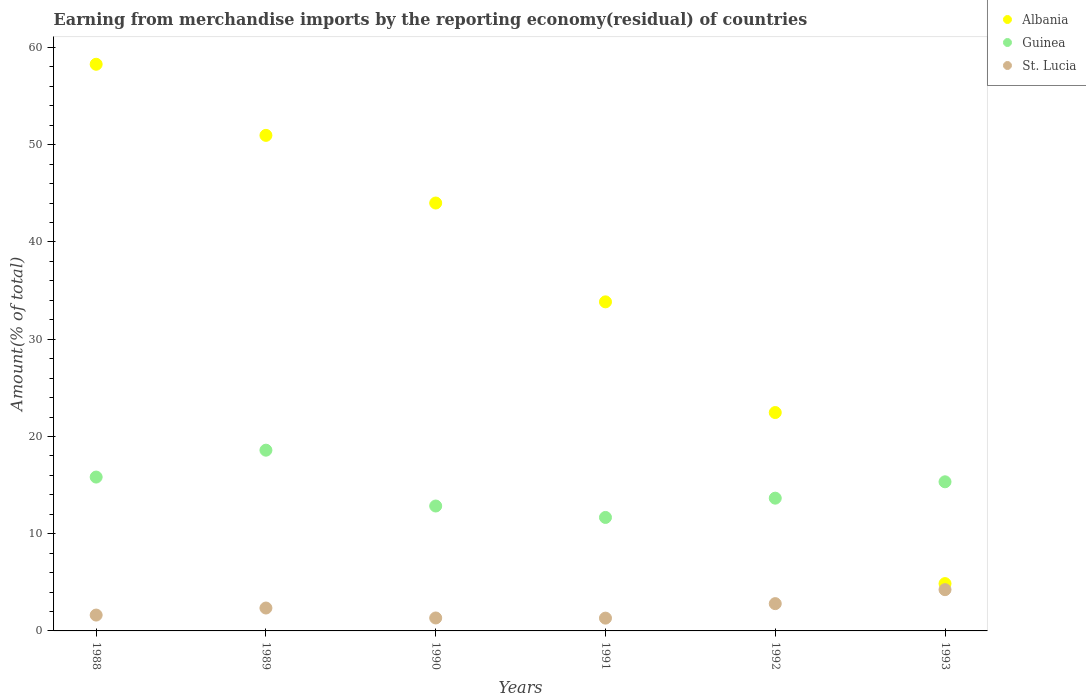What is the percentage of amount earned from merchandise imports in Guinea in 1993?
Keep it short and to the point. 15.34. Across all years, what is the maximum percentage of amount earned from merchandise imports in St. Lucia?
Your answer should be very brief. 4.24. Across all years, what is the minimum percentage of amount earned from merchandise imports in Albania?
Provide a succinct answer. 4.87. In which year was the percentage of amount earned from merchandise imports in Guinea maximum?
Provide a short and direct response. 1989. What is the total percentage of amount earned from merchandise imports in St. Lucia in the graph?
Keep it short and to the point. 13.68. What is the difference between the percentage of amount earned from merchandise imports in St. Lucia in 1989 and that in 1990?
Give a very brief answer. 1.02. What is the difference between the percentage of amount earned from merchandise imports in Guinea in 1991 and the percentage of amount earned from merchandise imports in Albania in 1988?
Your answer should be compact. -46.61. What is the average percentage of amount earned from merchandise imports in St. Lucia per year?
Your answer should be compact. 2.28. In the year 1993, what is the difference between the percentage of amount earned from merchandise imports in Albania and percentage of amount earned from merchandise imports in Guinea?
Your response must be concise. -10.47. In how many years, is the percentage of amount earned from merchandise imports in Guinea greater than 50 %?
Keep it short and to the point. 0. What is the ratio of the percentage of amount earned from merchandise imports in Albania in 1988 to that in 1993?
Provide a succinct answer. 11.98. What is the difference between the highest and the second highest percentage of amount earned from merchandise imports in St. Lucia?
Offer a terse response. 1.44. What is the difference between the highest and the lowest percentage of amount earned from merchandise imports in Albania?
Offer a terse response. 53.41. Is the sum of the percentage of amount earned from merchandise imports in St. Lucia in 1992 and 1993 greater than the maximum percentage of amount earned from merchandise imports in Albania across all years?
Your response must be concise. No. Is it the case that in every year, the sum of the percentage of amount earned from merchandise imports in Guinea and percentage of amount earned from merchandise imports in St. Lucia  is greater than the percentage of amount earned from merchandise imports in Albania?
Provide a short and direct response. No. Is the percentage of amount earned from merchandise imports in St. Lucia strictly less than the percentage of amount earned from merchandise imports in Guinea over the years?
Your answer should be compact. Yes. How many dotlines are there?
Make the answer very short. 3. Are the values on the major ticks of Y-axis written in scientific E-notation?
Provide a short and direct response. No. Does the graph contain grids?
Provide a short and direct response. No. Where does the legend appear in the graph?
Offer a terse response. Top right. What is the title of the graph?
Provide a succinct answer. Earning from merchandise imports by the reporting economy(residual) of countries. Does "Angola" appear as one of the legend labels in the graph?
Make the answer very short. No. What is the label or title of the Y-axis?
Offer a very short reply. Amount(% of total). What is the Amount(% of total) of Albania in 1988?
Keep it short and to the point. 58.28. What is the Amount(% of total) in Guinea in 1988?
Keep it short and to the point. 15.82. What is the Amount(% of total) in St. Lucia in 1988?
Offer a very short reply. 1.63. What is the Amount(% of total) in Albania in 1989?
Your response must be concise. 50.96. What is the Amount(% of total) in Guinea in 1989?
Your answer should be very brief. 18.59. What is the Amount(% of total) in St. Lucia in 1989?
Your answer should be compact. 2.35. What is the Amount(% of total) of Albania in 1990?
Offer a terse response. 44.01. What is the Amount(% of total) of Guinea in 1990?
Provide a short and direct response. 12.85. What is the Amount(% of total) of St. Lucia in 1990?
Keep it short and to the point. 1.33. What is the Amount(% of total) in Albania in 1991?
Offer a very short reply. 33.84. What is the Amount(% of total) in Guinea in 1991?
Offer a terse response. 11.67. What is the Amount(% of total) in St. Lucia in 1991?
Keep it short and to the point. 1.32. What is the Amount(% of total) in Albania in 1992?
Ensure brevity in your answer.  22.46. What is the Amount(% of total) of Guinea in 1992?
Keep it short and to the point. 13.65. What is the Amount(% of total) in St. Lucia in 1992?
Your answer should be compact. 2.81. What is the Amount(% of total) in Albania in 1993?
Your response must be concise. 4.87. What is the Amount(% of total) of Guinea in 1993?
Give a very brief answer. 15.34. What is the Amount(% of total) in St. Lucia in 1993?
Provide a short and direct response. 4.24. Across all years, what is the maximum Amount(% of total) in Albania?
Offer a very short reply. 58.28. Across all years, what is the maximum Amount(% of total) in Guinea?
Offer a very short reply. 18.59. Across all years, what is the maximum Amount(% of total) of St. Lucia?
Your answer should be very brief. 4.24. Across all years, what is the minimum Amount(% of total) in Albania?
Your answer should be very brief. 4.87. Across all years, what is the minimum Amount(% of total) in Guinea?
Offer a very short reply. 11.67. Across all years, what is the minimum Amount(% of total) in St. Lucia?
Keep it short and to the point. 1.32. What is the total Amount(% of total) in Albania in the graph?
Make the answer very short. 214.41. What is the total Amount(% of total) of Guinea in the graph?
Give a very brief answer. 87.92. What is the total Amount(% of total) in St. Lucia in the graph?
Make the answer very short. 13.68. What is the difference between the Amount(% of total) in Albania in 1988 and that in 1989?
Your answer should be very brief. 7.31. What is the difference between the Amount(% of total) of Guinea in 1988 and that in 1989?
Your response must be concise. -2.77. What is the difference between the Amount(% of total) in St. Lucia in 1988 and that in 1989?
Provide a short and direct response. -0.72. What is the difference between the Amount(% of total) in Albania in 1988 and that in 1990?
Your response must be concise. 14.27. What is the difference between the Amount(% of total) of Guinea in 1988 and that in 1990?
Keep it short and to the point. 2.98. What is the difference between the Amount(% of total) of St. Lucia in 1988 and that in 1990?
Provide a succinct answer. 0.3. What is the difference between the Amount(% of total) of Albania in 1988 and that in 1991?
Give a very brief answer. 24.43. What is the difference between the Amount(% of total) of Guinea in 1988 and that in 1991?
Give a very brief answer. 4.15. What is the difference between the Amount(% of total) of St. Lucia in 1988 and that in 1991?
Your answer should be very brief. 0.32. What is the difference between the Amount(% of total) in Albania in 1988 and that in 1992?
Offer a very short reply. 35.82. What is the difference between the Amount(% of total) in Guinea in 1988 and that in 1992?
Provide a succinct answer. 2.17. What is the difference between the Amount(% of total) in St. Lucia in 1988 and that in 1992?
Make the answer very short. -1.18. What is the difference between the Amount(% of total) of Albania in 1988 and that in 1993?
Make the answer very short. 53.41. What is the difference between the Amount(% of total) in Guinea in 1988 and that in 1993?
Offer a terse response. 0.49. What is the difference between the Amount(% of total) of St. Lucia in 1988 and that in 1993?
Your answer should be compact. -2.61. What is the difference between the Amount(% of total) in Albania in 1989 and that in 1990?
Provide a short and direct response. 6.96. What is the difference between the Amount(% of total) in Guinea in 1989 and that in 1990?
Your response must be concise. 5.74. What is the difference between the Amount(% of total) of St. Lucia in 1989 and that in 1990?
Offer a terse response. 1.02. What is the difference between the Amount(% of total) of Albania in 1989 and that in 1991?
Provide a short and direct response. 17.12. What is the difference between the Amount(% of total) in Guinea in 1989 and that in 1991?
Make the answer very short. 6.92. What is the difference between the Amount(% of total) in St. Lucia in 1989 and that in 1991?
Offer a very short reply. 1.04. What is the difference between the Amount(% of total) of Albania in 1989 and that in 1992?
Offer a terse response. 28.5. What is the difference between the Amount(% of total) of Guinea in 1989 and that in 1992?
Make the answer very short. 4.94. What is the difference between the Amount(% of total) of St. Lucia in 1989 and that in 1992?
Make the answer very short. -0.45. What is the difference between the Amount(% of total) of Albania in 1989 and that in 1993?
Keep it short and to the point. 46.1. What is the difference between the Amount(% of total) in Guinea in 1989 and that in 1993?
Offer a terse response. 3.25. What is the difference between the Amount(% of total) of St. Lucia in 1989 and that in 1993?
Make the answer very short. -1.89. What is the difference between the Amount(% of total) of Albania in 1990 and that in 1991?
Your answer should be very brief. 10.16. What is the difference between the Amount(% of total) of Guinea in 1990 and that in 1991?
Provide a short and direct response. 1.17. What is the difference between the Amount(% of total) of St. Lucia in 1990 and that in 1991?
Offer a very short reply. 0.02. What is the difference between the Amount(% of total) of Albania in 1990 and that in 1992?
Your answer should be compact. 21.55. What is the difference between the Amount(% of total) of Guinea in 1990 and that in 1992?
Your answer should be compact. -0.81. What is the difference between the Amount(% of total) in St. Lucia in 1990 and that in 1992?
Make the answer very short. -1.47. What is the difference between the Amount(% of total) of Albania in 1990 and that in 1993?
Offer a terse response. 39.14. What is the difference between the Amount(% of total) of Guinea in 1990 and that in 1993?
Offer a very short reply. -2.49. What is the difference between the Amount(% of total) in St. Lucia in 1990 and that in 1993?
Make the answer very short. -2.91. What is the difference between the Amount(% of total) of Albania in 1991 and that in 1992?
Your answer should be very brief. 11.38. What is the difference between the Amount(% of total) of Guinea in 1991 and that in 1992?
Your response must be concise. -1.98. What is the difference between the Amount(% of total) in St. Lucia in 1991 and that in 1992?
Your response must be concise. -1.49. What is the difference between the Amount(% of total) of Albania in 1991 and that in 1993?
Provide a succinct answer. 28.98. What is the difference between the Amount(% of total) in Guinea in 1991 and that in 1993?
Give a very brief answer. -3.67. What is the difference between the Amount(% of total) of St. Lucia in 1991 and that in 1993?
Make the answer very short. -2.93. What is the difference between the Amount(% of total) of Albania in 1992 and that in 1993?
Your answer should be compact. 17.59. What is the difference between the Amount(% of total) of Guinea in 1992 and that in 1993?
Provide a short and direct response. -1.68. What is the difference between the Amount(% of total) of St. Lucia in 1992 and that in 1993?
Your response must be concise. -1.44. What is the difference between the Amount(% of total) in Albania in 1988 and the Amount(% of total) in Guinea in 1989?
Make the answer very short. 39.69. What is the difference between the Amount(% of total) of Albania in 1988 and the Amount(% of total) of St. Lucia in 1989?
Give a very brief answer. 55.92. What is the difference between the Amount(% of total) in Guinea in 1988 and the Amount(% of total) in St. Lucia in 1989?
Your answer should be very brief. 13.47. What is the difference between the Amount(% of total) of Albania in 1988 and the Amount(% of total) of Guinea in 1990?
Your answer should be very brief. 45.43. What is the difference between the Amount(% of total) of Albania in 1988 and the Amount(% of total) of St. Lucia in 1990?
Provide a succinct answer. 56.94. What is the difference between the Amount(% of total) in Guinea in 1988 and the Amount(% of total) in St. Lucia in 1990?
Offer a terse response. 14.49. What is the difference between the Amount(% of total) of Albania in 1988 and the Amount(% of total) of Guinea in 1991?
Make the answer very short. 46.61. What is the difference between the Amount(% of total) in Albania in 1988 and the Amount(% of total) in St. Lucia in 1991?
Ensure brevity in your answer.  56.96. What is the difference between the Amount(% of total) in Guinea in 1988 and the Amount(% of total) in St. Lucia in 1991?
Provide a short and direct response. 14.51. What is the difference between the Amount(% of total) of Albania in 1988 and the Amount(% of total) of Guinea in 1992?
Your answer should be compact. 44.62. What is the difference between the Amount(% of total) of Albania in 1988 and the Amount(% of total) of St. Lucia in 1992?
Your answer should be compact. 55.47. What is the difference between the Amount(% of total) of Guinea in 1988 and the Amount(% of total) of St. Lucia in 1992?
Your response must be concise. 13.02. What is the difference between the Amount(% of total) of Albania in 1988 and the Amount(% of total) of Guinea in 1993?
Your response must be concise. 42.94. What is the difference between the Amount(% of total) in Albania in 1988 and the Amount(% of total) in St. Lucia in 1993?
Offer a very short reply. 54.03. What is the difference between the Amount(% of total) of Guinea in 1988 and the Amount(% of total) of St. Lucia in 1993?
Make the answer very short. 11.58. What is the difference between the Amount(% of total) in Albania in 1989 and the Amount(% of total) in Guinea in 1990?
Provide a short and direct response. 38.12. What is the difference between the Amount(% of total) of Albania in 1989 and the Amount(% of total) of St. Lucia in 1990?
Make the answer very short. 49.63. What is the difference between the Amount(% of total) in Guinea in 1989 and the Amount(% of total) in St. Lucia in 1990?
Your answer should be very brief. 17.26. What is the difference between the Amount(% of total) in Albania in 1989 and the Amount(% of total) in Guinea in 1991?
Make the answer very short. 39.29. What is the difference between the Amount(% of total) of Albania in 1989 and the Amount(% of total) of St. Lucia in 1991?
Keep it short and to the point. 49.65. What is the difference between the Amount(% of total) of Guinea in 1989 and the Amount(% of total) of St. Lucia in 1991?
Your answer should be very brief. 17.27. What is the difference between the Amount(% of total) of Albania in 1989 and the Amount(% of total) of Guinea in 1992?
Keep it short and to the point. 37.31. What is the difference between the Amount(% of total) in Albania in 1989 and the Amount(% of total) in St. Lucia in 1992?
Keep it short and to the point. 48.16. What is the difference between the Amount(% of total) of Guinea in 1989 and the Amount(% of total) of St. Lucia in 1992?
Keep it short and to the point. 15.78. What is the difference between the Amount(% of total) in Albania in 1989 and the Amount(% of total) in Guinea in 1993?
Keep it short and to the point. 35.63. What is the difference between the Amount(% of total) of Albania in 1989 and the Amount(% of total) of St. Lucia in 1993?
Make the answer very short. 46.72. What is the difference between the Amount(% of total) of Guinea in 1989 and the Amount(% of total) of St. Lucia in 1993?
Make the answer very short. 14.34. What is the difference between the Amount(% of total) in Albania in 1990 and the Amount(% of total) in Guinea in 1991?
Make the answer very short. 32.34. What is the difference between the Amount(% of total) in Albania in 1990 and the Amount(% of total) in St. Lucia in 1991?
Provide a short and direct response. 42.69. What is the difference between the Amount(% of total) in Guinea in 1990 and the Amount(% of total) in St. Lucia in 1991?
Keep it short and to the point. 11.53. What is the difference between the Amount(% of total) of Albania in 1990 and the Amount(% of total) of Guinea in 1992?
Your response must be concise. 30.35. What is the difference between the Amount(% of total) in Albania in 1990 and the Amount(% of total) in St. Lucia in 1992?
Ensure brevity in your answer.  41.2. What is the difference between the Amount(% of total) in Guinea in 1990 and the Amount(% of total) in St. Lucia in 1992?
Provide a succinct answer. 10.04. What is the difference between the Amount(% of total) of Albania in 1990 and the Amount(% of total) of Guinea in 1993?
Offer a terse response. 28.67. What is the difference between the Amount(% of total) in Albania in 1990 and the Amount(% of total) in St. Lucia in 1993?
Provide a short and direct response. 39.76. What is the difference between the Amount(% of total) of Guinea in 1990 and the Amount(% of total) of St. Lucia in 1993?
Give a very brief answer. 8.6. What is the difference between the Amount(% of total) of Albania in 1991 and the Amount(% of total) of Guinea in 1992?
Keep it short and to the point. 20.19. What is the difference between the Amount(% of total) in Albania in 1991 and the Amount(% of total) in St. Lucia in 1992?
Provide a succinct answer. 31.04. What is the difference between the Amount(% of total) in Guinea in 1991 and the Amount(% of total) in St. Lucia in 1992?
Give a very brief answer. 8.86. What is the difference between the Amount(% of total) in Albania in 1991 and the Amount(% of total) in Guinea in 1993?
Make the answer very short. 18.51. What is the difference between the Amount(% of total) in Albania in 1991 and the Amount(% of total) in St. Lucia in 1993?
Offer a terse response. 29.6. What is the difference between the Amount(% of total) in Guinea in 1991 and the Amount(% of total) in St. Lucia in 1993?
Provide a short and direct response. 7.43. What is the difference between the Amount(% of total) of Albania in 1992 and the Amount(% of total) of Guinea in 1993?
Make the answer very short. 7.12. What is the difference between the Amount(% of total) in Albania in 1992 and the Amount(% of total) in St. Lucia in 1993?
Provide a short and direct response. 18.22. What is the difference between the Amount(% of total) in Guinea in 1992 and the Amount(% of total) in St. Lucia in 1993?
Make the answer very short. 9.41. What is the average Amount(% of total) in Albania per year?
Offer a terse response. 35.74. What is the average Amount(% of total) in Guinea per year?
Provide a short and direct response. 14.65. What is the average Amount(% of total) of St. Lucia per year?
Offer a terse response. 2.28. In the year 1988, what is the difference between the Amount(% of total) of Albania and Amount(% of total) of Guinea?
Make the answer very short. 42.45. In the year 1988, what is the difference between the Amount(% of total) in Albania and Amount(% of total) in St. Lucia?
Give a very brief answer. 56.65. In the year 1988, what is the difference between the Amount(% of total) in Guinea and Amount(% of total) in St. Lucia?
Offer a very short reply. 14.19. In the year 1989, what is the difference between the Amount(% of total) of Albania and Amount(% of total) of Guinea?
Your response must be concise. 32.38. In the year 1989, what is the difference between the Amount(% of total) in Albania and Amount(% of total) in St. Lucia?
Your answer should be very brief. 48.61. In the year 1989, what is the difference between the Amount(% of total) in Guinea and Amount(% of total) in St. Lucia?
Your answer should be compact. 16.23. In the year 1990, what is the difference between the Amount(% of total) in Albania and Amount(% of total) in Guinea?
Offer a very short reply. 31.16. In the year 1990, what is the difference between the Amount(% of total) of Albania and Amount(% of total) of St. Lucia?
Provide a short and direct response. 42.67. In the year 1990, what is the difference between the Amount(% of total) of Guinea and Amount(% of total) of St. Lucia?
Ensure brevity in your answer.  11.51. In the year 1991, what is the difference between the Amount(% of total) of Albania and Amount(% of total) of Guinea?
Ensure brevity in your answer.  22.17. In the year 1991, what is the difference between the Amount(% of total) of Albania and Amount(% of total) of St. Lucia?
Ensure brevity in your answer.  32.53. In the year 1991, what is the difference between the Amount(% of total) of Guinea and Amount(% of total) of St. Lucia?
Your answer should be compact. 10.36. In the year 1992, what is the difference between the Amount(% of total) of Albania and Amount(% of total) of Guinea?
Give a very brief answer. 8.81. In the year 1992, what is the difference between the Amount(% of total) in Albania and Amount(% of total) in St. Lucia?
Ensure brevity in your answer.  19.65. In the year 1992, what is the difference between the Amount(% of total) in Guinea and Amount(% of total) in St. Lucia?
Give a very brief answer. 10.85. In the year 1993, what is the difference between the Amount(% of total) of Albania and Amount(% of total) of Guinea?
Your response must be concise. -10.47. In the year 1993, what is the difference between the Amount(% of total) of Albania and Amount(% of total) of St. Lucia?
Make the answer very short. 0.62. In the year 1993, what is the difference between the Amount(% of total) in Guinea and Amount(% of total) in St. Lucia?
Your answer should be compact. 11.09. What is the ratio of the Amount(% of total) in Albania in 1988 to that in 1989?
Provide a short and direct response. 1.14. What is the ratio of the Amount(% of total) of Guinea in 1988 to that in 1989?
Give a very brief answer. 0.85. What is the ratio of the Amount(% of total) of St. Lucia in 1988 to that in 1989?
Provide a short and direct response. 0.69. What is the ratio of the Amount(% of total) in Albania in 1988 to that in 1990?
Your answer should be very brief. 1.32. What is the ratio of the Amount(% of total) of Guinea in 1988 to that in 1990?
Ensure brevity in your answer.  1.23. What is the ratio of the Amount(% of total) of St. Lucia in 1988 to that in 1990?
Make the answer very short. 1.22. What is the ratio of the Amount(% of total) of Albania in 1988 to that in 1991?
Your answer should be compact. 1.72. What is the ratio of the Amount(% of total) of Guinea in 1988 to that in 1991?
Offer a terse response. 1.36. What is the ratio of the Amount(% of total) in St. Lucia in 1988 to that in 1991?
Your answer should be very brief. 1.24. What is the ratio of the Amount(% of total) in Albania in 1988 to that in 1992?
Your answer should be compact. 2.59. What is the ratio of the Amount(% of total) of Guinea in 1988 to that in 1992?
Provide a short and direct response. 1.16. What is the ratio of the Amount(% of total) of St. Lucia in 1988 to that in 1992?
Offer a very short reply. 0.58. What is the ratio of the Amount(% of total) of Albania in 1988 to that in 1993?
Keep it short and to the point. 11.98. What is the ratio of the Amount(% of total) in Guinea in 1988 to that in 1993?
Make the answer very short. 1.03. What is the ratio of the Amount(% of total) in St. Lucia in 1988 to that in 1993?
Offer a terse response. 0.38. What is the ratio of the Amount(% of total) in Albania in 1989 to that in 1990?
Provide a short and direct response. 1.16. What is the ratio of the Amount(% of total) of Guinea in 1989 to that in 1990?
Your answer should be compact. 1.45. What is the ratio of the Amount(% of total) of St. Lucia in 1989 to that in 1990?
Ensure brevity in your answer.  1.77. What is the ratio of the Amount(% of total) in Albania in 1989 to that in 1991?
Offer a terse response. 1.51. What is the ratio of the Amount(% of total) of Guinea in 1989 to that in 1991?
Give a very brief answer. 1.59. What is the ratio of the Amount(% of total) of St. Lucia in 1989 to that in 1991?
Keep it short and to the point. 1.79. What is the ratio of the Amount(% of total) of Albania in 1989 to that in 1992?
Your answer should be compact. 2.27. What is the ratio of the Amount(% of total) of Guinea in 1989 to that in 1992?
Your answer should be very brief. 1.36. What is the ratio of the Amount(% of total) in St. Lucia in 1989 to that in 1992?
Your answer should be compact. 0.84. What is the ratio of the Amount(% of total) in Albania in 1989 to that in 1993?
Your response must be concise. 10.47. What is the ratio of the Amount(% of total) in Guinea in 1989 to that in 1993?
Make the answer very short. 1.21. What is the ratio of the Amount(% of total) in St. Lucia in 1989 to that in 1993?
Your response must be concise. 0.55. What is the ratio of the Amount(% of total) of Albania in 1990 to that in 1991?
Your answer should be compact. 1.3. What is the ratio of the Amount(% of total) of Guinea in 1990 to that in 1991?
Give a very brief answer. 1.1. What is the ratio of the Amount(% of total) of St. Lucia in 1990 to that in 1991?
Make the answer very short. 1.01. What is the ratio of the Amount(% of total) in Albania in 1990 to that in 1992?
Your answer should be very brief. 1.96. What is the ratio of the Amount(% of total) in Guinea in 1990 to that in 1992?
Your answer should be compact. 0.94. What is the ratio of the Amount(% of total) in St. Lucia in 1990 to that in 1992?
Offer a very short reply. 0.47. What is the ratio of the Amount(% of total) of Albania in 1990 to that in 1993?
Give a very brief answer. 9.04. What is the ratio of the Amount(% of total) of Guinea in 1990 to that in 1993?
Ensure brevity in your answer.  0.84. What is the ratio of the Amount(% of total) in St. Lucia in 1990 to that in 1993?
Your answer should be compact. 0.31. What is the ratio of the Amount(% of total) of Albania in 1991 to that in 1992?
Your answer should be very brief. 1.51. What is the ratio of the Amount(% of total) of Guinea in 1991 to that in 1992?
Your response must be concise. 0.85. What is the ratio of the Amount(% of total) of St. Lucia in 1991 to that in 1992?
Your answer should be compact. 0.47. What is the ratio of the Amount(% of total) of Albania in 1991 to that in 1993?
Offer a very short reply. 6.95. What is the ratio of the Amount(% of total) in Guinea in 1991 to that in 1993?
Your answer should be very brief. 0.76. What is the ratio of the Amount(% of total) in St. Lucia in 1991 to that in 1993?
Make the answer very short. 0.31. What is the ratio of the Amount(% of total) in Albania in 1992 to that in 1993?
Your answer should be very brief. 4.62. What is the ratio of the Amount(% of total) in Guinea in 1992 to that in 1993?
Offer a terse response. 0.89. What is the ratio of the Amount(% of total) in St. Lucia in 1992 to that in 1993?
Make the answer very short. 0.66. What is the difference between the highest and the second highest Amount(% of total) of Albania?
Your answer should be compact. 7.31. What is the difference between the highest and the second highest Amount(% of total) of Guinea?
Make the answer very short. 2.77. What is the difference between the highest and the second highest Amount(% of total) in St. Lucia?
Keep it short and to the point. 1.44. What is the difference between the highest and the lowest Amount(% of total) of Albania?
Offer a terse response. 53.41. What is the difference between the highest and the lowest Amount(% of total) of Guinea?
Offer a terse response. 6.92. What is the difference between the highest and the lowest Amount(% of total) in St. Lucia?
Offer a terse response. 2.93. 